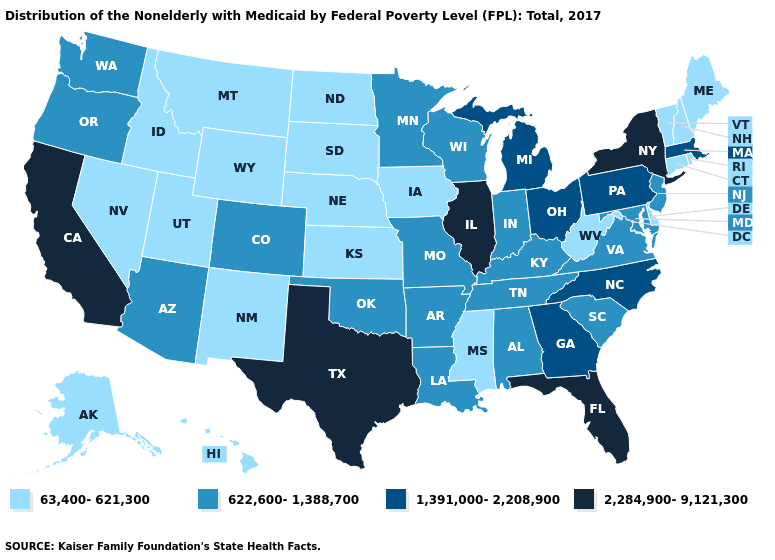Does Virginia have the same value as New Jersey?
Concise answer only. Yes. Which states have the lowest value in the USA?
Concise answer only. Alaska, Connecticut, Delaware, Hawaii, Idaho, Iowa, Kansas, Maine, Mississippi, Montana, Nebraska, Nevada, New Hampshire, New Mexico, North Dakota, Rhode Island, South Dakota, Utah, Vermont, West Virginia, Wyoming. What is the value of Missouri?
Answer briefly. 622,600-1,388,700. Among the states that border Utah , does Idaho have the highest value?
Give a very brief answer. No. What is the highest value in the USA?
Give a very brief answer. 2,284,900-9,121,300. Is the legend a continuous bar?
Be succinct. No. What is the value of North Carolina?
Write a very short answer. 1,391,000-2,208,900. Among the states that border New Hampshire , which have the lowest value?
Answer briefly. Maine, Vermont. What is the value of South Dakota?
Be succinct. 63,400-621,300. Name the states that have a value in the range 622,600-1,388,700?
Write a very short answer. Alabama, Arizona, Arkansas, Colorado, Indiana, Kentucky, Louisiana, Maryland, Minnesota, Missouri, New Jersey, Oklahoma, Oregon, South Carolina, Tennessee, Virginia, Washington, Wisconsin. Which states have the highest value in the USA?
Be succinct. California, Florida, Illinois, New York, Texas. Does Illinois have the highest value in the USA?
Concise answer only. Yes. What is the highest value in the West ?
Short answer required. 2,284,900-9,121,300. Among the states that border California , does Arizona have the highest value?
Give a very brief answer. Yes. Does Kansas have the lowest value in the USA?
Quick response, please. Yes. 